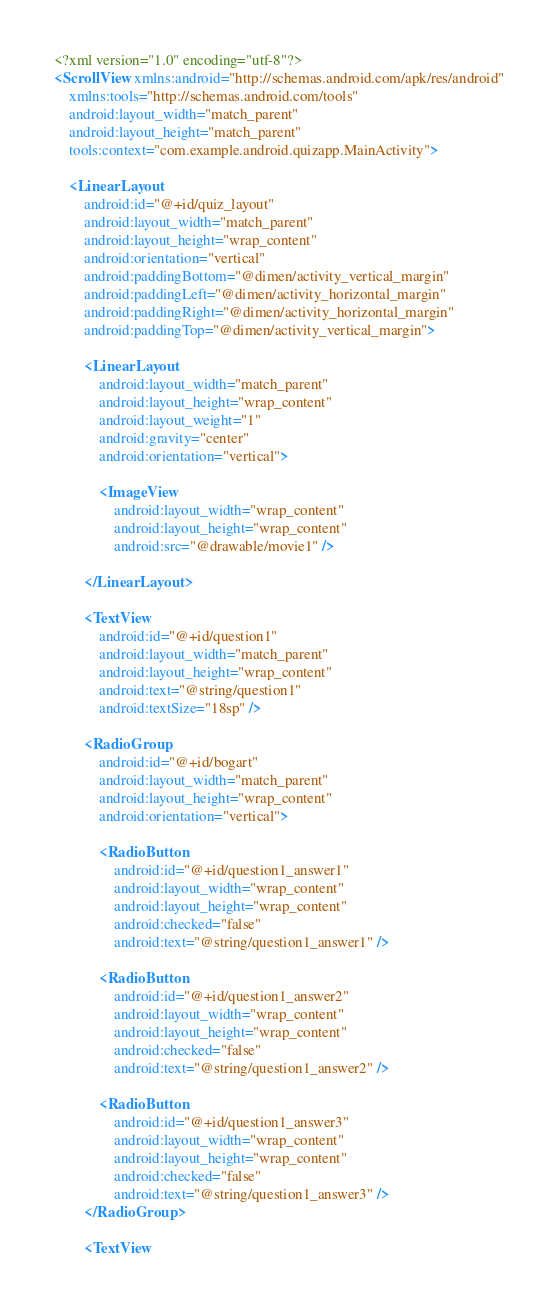Convert code to text. <code><loc_0><loc_0><loc_500><loc_500><_XML_><?xml version="1.0" encoding="utf-8"?>
<ScrollView xmlns:android="http://schemas.android.com/apk/res/android"
    xmlns:tools="http://schemas.android.com/tools"
    android:layout_width="match_parent"
    android:layout_height="match_parent"
    tools:context="com.example.android.quizapp.MainActivity">

    <LinearLayout
        android:id="@+id/quiz_layout"
        android:layout_width="match_parent"
        android:layout_height="wrap_content"
        android:orientation="vertical"
        android:paddingBottom="@dimen/activity_vertical_margin"
        android:paddingLeft="@dimen/activity_horizontal_margin"
        android:paddingRight="@dimen/activity_horizontal_margin"
        android:paddingTop="@dimen/activity_vertical_margin">

        <LinearLayout
            android:layout_width="match_parent"
            android:layout_height="wrap_content"
            android:layout_weight="1"
            android:gravity="center"
            android:orientation="vertical">

            <ImageView
                android:layout_width="wrap_content"
                android:layout_height="wrap_content"
                android:src="@drawable/movie1" />

        </LinearLayout>

        <TextView
            android:id="@+id/question1"
            android:layout_width="match_parent"
            android:layout_height="wrap_content"
            android:text="@string/question1"
            android:textSize="18sp" />

        <RadioGroup
            android:id="@+id/bogart"
            android:layout_width="match_parent"
            android:layout_height="wrap_content"
            android:orientation="vertical">

            <RadioButton
                android:id="@+id/question1_answer1"
                android:layout_width="wrap_content"
                android:layout_height="wrap_content"
                android:checked="false"
                android:text="@string/question1_answer1" />

            <RadioButton
                android:id="@+id/question1_answer2"
                android:layout_width="wrap_content"
                android:layout_height="wrap_content"
                android:checked="false"
                android:text="@string/question1_answer2" />

            <RadioButton
                android:id="@+id/question1_answer3"
                android:layout_width="wrap_content"
                android:layout_height="wrap_content"
                android:checked="false"
                android:text="@string/question1_answer3" />
        </RadioGroup>

        <TextView</code> 